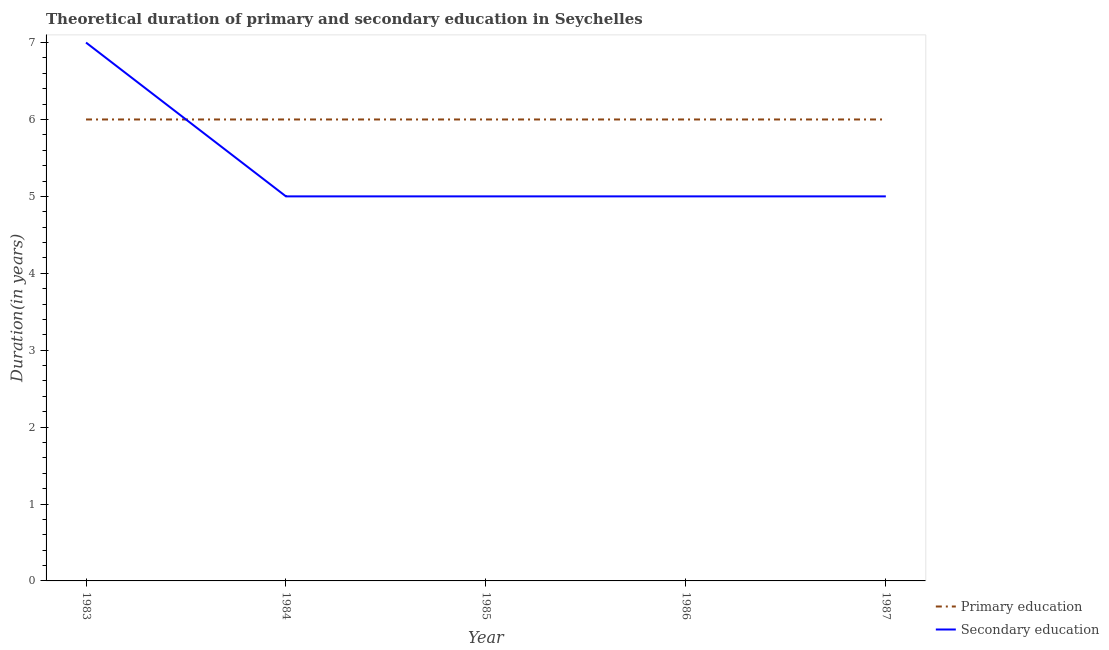How many different coloured lines are there?
Offer a terse response. 2. Does the line corresponding to duration of secondary education intersect with the line corresponding to duration of primary education?
Offer a very short reply. Yes. What is the duration of secondary education in 1984?
Give a very brief answer. 5. Across all years, what is the maximum duration of primary education?
Give a very brief answer. 6. In which year was the duration of primary education maximum?
Make the answer very short. 1983. In which year was the duration of primary education minimum?
Give a very brief answer. 1983. What is the total duration of primary education in the graph?
Give a very brief answer. 30. What is the difference between the duration of primary education in 1986 and that in 1987?
Keep it short and to the point. 0. What is the difference between the duration of primary education in 1985 and the duration of secondary education in 1984?
Provide a succinct answer. 1. What is the average duration of primary education per year?
Offer a very short reply. 6. In the year 1983, what is the difference between the duration of primary education and duration of secondary education?
Give a very brief answer. -1. Is the duration of primary education in 1984 less than that in 1986?
Make the answer very short. No. Is the difference between the duration of primary education in 1983 and 1984 greater than the difference between the duration of secondary education in 1983 and 1984?
Offer a very short reply. No. What is the difference between the highest and the second highest duration of secondary education?
Make the answer very short. 2. What is the difference between the highest and the lowest duration of secondary education?
Give a very brief answer. 2. In how many years, is the duration of primary education greater than the average duration of primary education taken over all years?
Keep it short and to the point. 0. Is the duration of primary education strictly greater than the duration of secondary education over the years?
Provide a succinct answer. No. How many lines are there?
Your answer should be compact. 2. How many years are there in the graph?
Provide a short and direct response. 5. Does the graph contain any zero values?
Provide a short and direct response. No. Where does the legend appear in the graph?
Your answer should be very brief. Bottom right. How many legend labels are there?
Your answer should be compact. 2. How are the legend labels stacked?
Keep it short and to the point. Vertical. What is the title of the graph?
Provide a short and direct response. Theoretical duration of primary and secondary education in Seychelles. What is the label or title of the X-axis?
Your response must be concise. Year. What is the label or title of the Y-axis?
Your answer should be very brief. Duration(in years). What is the Duration(in years) of Primary education in 1983?
Ensure brevity in your answer.  6. What is the Duration(in years) of Secondary education in 1983?
Make the answer very short. 7. What is the Duration(in years) of Secondary education in 1985?
Your answer should be compact. 5. What is the Duration(in years) of Primary education in 1986?
Provide a succinct answer. 6. What is the Duration(in years) in Secondary education in 1986?
Give a very brief answer. 5. What is the Duration(in years) in Primary education in 1987?
Your answer should be compact. 6. Across all years, what is the minimum Duration(in years) of Secondary education?
Your answer should be very brief. 5. What is the difference between the Duration(in years) of Primary education in 1983 and that in 1984?
Provide a succinct answer. 0. What is the difference between the Duration(in years) of Secondary education in 1983 and that in 1985?
Ensure brevity in your answer.  2. What is the difference between the Duration(in years) of Primary education in 1983 and that in 1986?
Provide a succinct answer. 0. What is the difference between the Duration(in years) of Primary education in 1984 and that in 1985?
Make the answer very short. 0. What is the difference between the Duration(in years) of Primary education in 1984 and that in 1987?
Ensure brevity in your answer.  0. What is the difference between the Duration(in years) of Primary education in 1985 and that in 1987?
Your answer should be compact. 0. What is the difference between the Duration(in years) in Primary education in 1986 and that in 1987?
Your response must be concise. 0. What is the difference between the Duration(in years) in Secondary education in 1986 and that in 1987?
Your answer should be very brief. 0. What is the difference between the Duration(in years) in Primary education in 1984 and the Duration(in years) in Secondary education in 1986?
Your response must be concise. 1. What is the difference between the Duration(in years) in Primary education in 1984 and the Duration(in years) in Secondary education in 1987?
Your answer should be compact. 1. What is the average Duration(in years) in Primary education per year?
Your response must be concise. 6. What is the average Duration(in years) of Secondary education per year?
Provide a succinct answer. 5.4. In the year 1984, what is the difference between the Duration(in years) in Primary education and Duration(in years) in Secondary education?
Your response must be concise. 1. In the year 1986, what is the difference between the Duration(in years) of Primary education and Duration(in years) of Secondary education?
Make the answer very short. 1. What is the ratio of the Duration(in years) in Primary education in 1983 to that in 1984?
Provide a short and direct response. 1. What is the ratio of the Duration(in years) in Secondary education in 1983 to that in 1984?
Your answer should be compact. 1.4. What is the ratio of the Duration(in years) in Primary education in 1983 to that in 1985?
Your response must be concise. 1. What is the ratio of the Duration(in years) in Primary education in 1983 to that in 1986?
Your response must be concise. 1. What is the ratio of the Duration(in years) of Secondary education in 1983 to that in 1987?
Your response must be concise. 1.4. What is the ratio of the Duration(in years) of Primary education in 1984 to that in 1985?
Your answer should be compact. 1. What is the ratio of the Duration(in years) in Secondary education in 1984 to that in 1985?
Ensure brevity in your answer.  1. What is the ratio of the Duration(in years) in Secondary education in 1984 to that in 1986?
Ensure brevity in your answer.  1. What is the ratio of the Duration(in years) of Primary education in 1984 to that in 1987?
Keep it short and to the point. 1. What is the ratio of the Duration(in years) of Primary education in 1985 to that in 1986?
Give a very brief answer. 1. What is the ratio of the Duration(in years) of Secondary education in 1985 to that in 1986?
Offer a terse response. 1. What is the ratio of the Duration(in years) of Primary education in 1986 to that in 1987?
Offer a terse response. 1. What is the difference between the highest and the second highest Duration(in years) in Primary education?
Make the answer very short. 0. What is the difference between the highest and the lowest Duration(in years) in Primary education?
Keep it short and to the point. 0. 